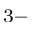Convert formula to latex. <formula><loc_0><loc_0><loc_500><loc_500>^ { 3 - }</formula> 